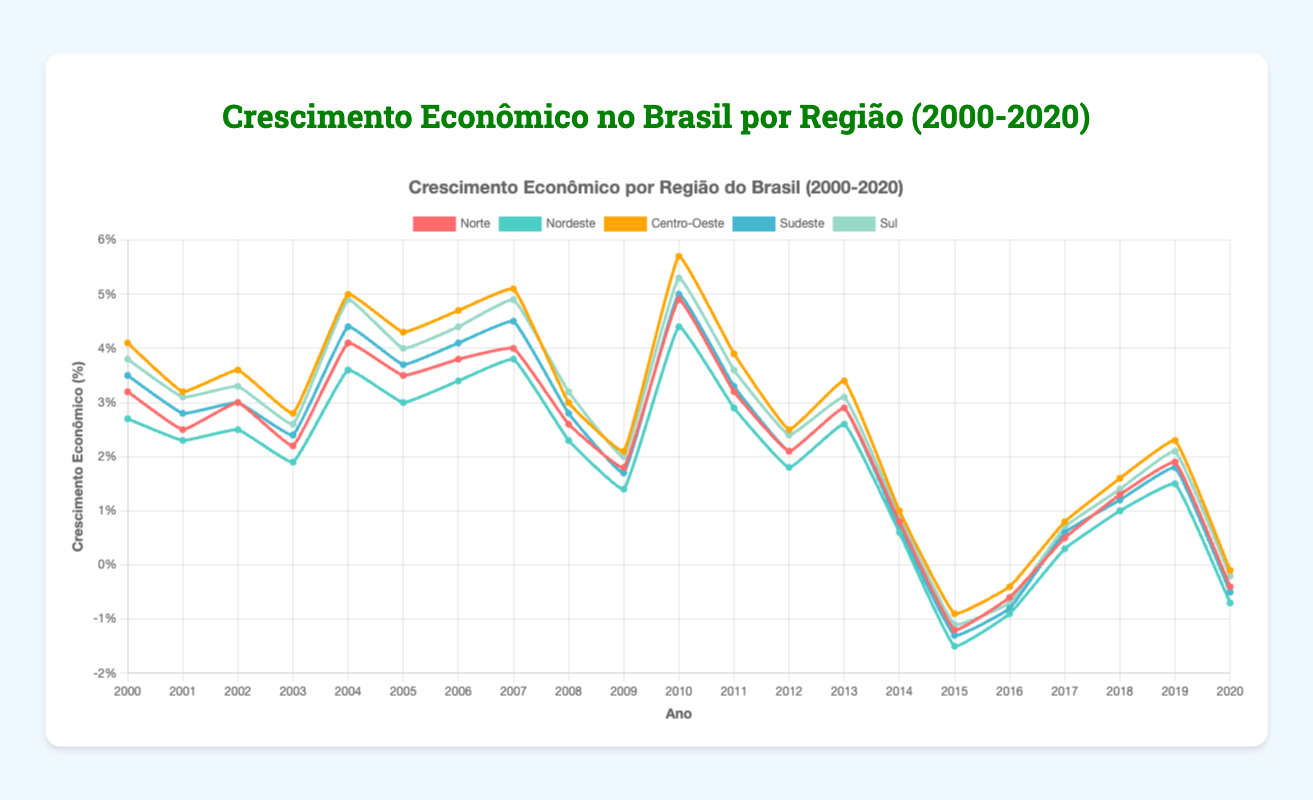What was the economic growth rate in the Center-West region in 2004? Referring to the figure, look for the value of the Center-West region in the year 2004. The chart shows this value as 5.0%.
Answer: 5.0% How did the Southeast's economic growth rate change from 2010 to 2020? Locate the data points for the Southeast region for the years 2010 and 2020 on the figure. The economic growth rate in 2010 was 5.0%, and in 2020 it was -0.5%. The change is 5.0% - (-0.5%) = 5.5%.
Answer: 5.5% Which region had the highest economic growth rate in 2010? Identify the highest data point for the year 2010. The North region had an economic growth rate of 4.9%, the Northeast 4.4%, the Center-West 5.7%, the Southeast 5.0%, and the South 5.3%. The Center-West region had the highest growth rate in 2010.
Answer: Center-West In which year did the South region experience the lowest economic growth rate? Look at the trend line for the South region and identify the lowest point. The lowest growth rate for the South occurred in 2015, where it was -1.1%.
Answer: 2015 Compare the average economic growth rate of the North and Northeast regions between 2000 and 2020. Which region had a higher average growth rate? Calculate the average growth rate for both regions from 2000 to 2020. Sum the values for each region and divide by the number of years (21). The North has an average growth rate of (3.2+2.5+3.0+2.2+4.1+3.5+3.8+4.0+2.6+1.8+4.9+3.2+2.1+2.9+0.8-1.2-0.6+0.5+1.3+1.9-0.4) / 21 ≈ 2.30%. The Northeast has an average growth rate of (2.7+2.3+2.5+1.9+3.6+3.0+3.4+3.8+2.3+1.4+4.4+2.9+1.8+2.6+0.6-1.5-0.9+0.3+1.0+1.5-0.7) / 21 ≈ 1.94%. The North had a higher average growth rate.
Answer: North During which period did all regions experience economic growth rates below zero? Refer to the figure and locate the periods where all regions' lines dip below zero. The period was from 2015 to 2016.
Answer: 2015-2016 What was the difference in economic growth between the Southeast and South regions in 2009? Check the economic growth rates for both the Southeast and South in 2009. The Southeast was 1.7%, and the South was 2.0%. The difference is 2.0% - 1.7% = 0.3%.
Answer: 0.3% Which region had the most stable (least fluctuating) economic growth rate from 2000 to 2020? Assess the lines on the figure to identify which region exhibits the least fluctuations. The Northeast region has the smoothest line with fewer drastic changes.
Answer: Northeast When did the North region experience its highest growth rate, and what was the value? Look for the highest point on the North region's line. The highest growth rate occurred in 2010, with a value of 4.9%.
Answer: 2010, 4.9% How many years did the Center-West region experience a growth rate above 4.0%? Count the data points above 4.0% on the Center-West line. These years are 2000, 2004, 2005, 2006, 2007, 2010, which totals 6 years.
Answer: 6 